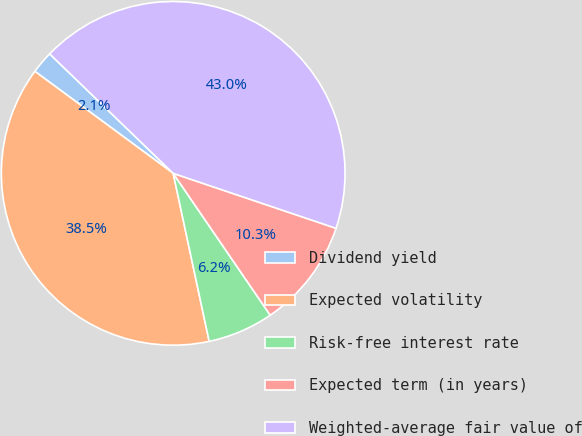<chart> <loc_0><loc_0><loc_500><loc_500><pie_chart><fcel>Dividend yield<fcel>Expected volatility<fcel>Risk-free interest rate<fcel>Expected term (in years)<fcel>Weighted-average fair value of<nl><fcel>2.12%<fcel>38.47%<fcel>6.19%<fcel>10.27%<fcel>42.95%<nl></chart> 